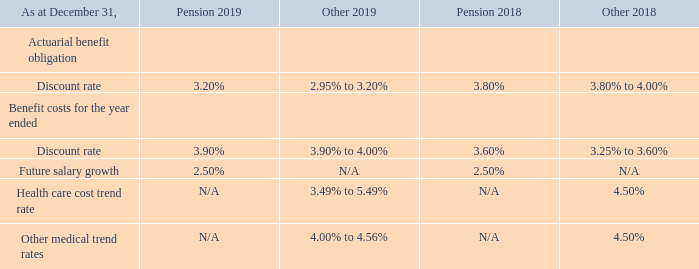The following are the significant assumptions adopted in measuring the Company’s pension and other benefit obligations:
For certain Canadian post-retirement plans the above trend rates are applicable for 2019 to 2024 which will increase linearly to 4.75% in 2029 and grading down to an ultimate rate of 3.57% per annum in 2040 and thereafter.
How will the trend rates for Canadian post-retirement plans change between the current period to 2029 and in 2040 and after respectively? Increase linearly to 4.75%, grading down to an ultimate rate of 3.57% per annum in 2040 and thereafter. What are the respective pension discount rates for actuarial benefit obligation in 2019 and 2018 respectively? 3.20%, 3.80%. What are the respective pension discount rates for benefit costs in 2019 and 2018 respectively? 3.90%, 3.60%. What is the total pension discount rate for actuarial benefit obligation for 2018 and 2019?
Answer scale should be: percent. 3.20 + 3.80 
Answer: 7. What is the percentage change in the pension discount rate for actuarial benefit obligations between 2018 and 2019?
Answer scale should be: percent. 3.20 - 3.80 
Answer: -0.6. What is the difference in future salary growth assumed under pension 2018 and 2019?
Answer scale should be: percent. 2.50 - 2.50 
Answer: 0. 